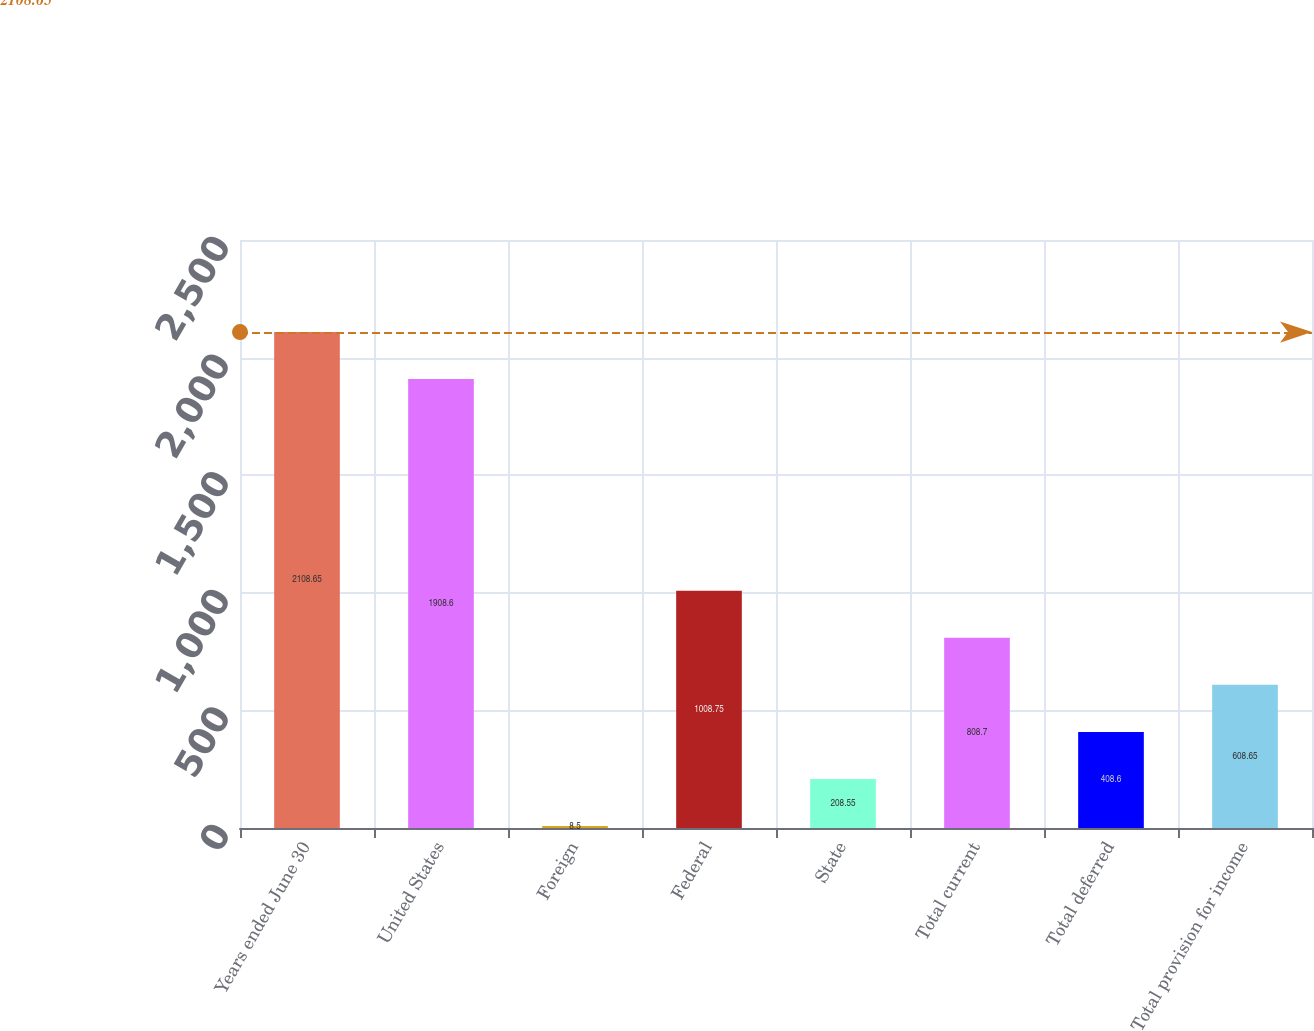Convert chart. <chart><loc_0><loc_0><loc_500><loc_500><bar_chart><fcel>Years ended June 30<fcel>United States<fcel>Foreign<fcel>Federal<fcel>State<fcel>Total current<fcel>Total deferred<fcel>Total provision for income<nl><fcel>2108.65<fcel>1908.6<fcel>8.5<fcel>1008.75<fcel>208.55<fcel>808.7<fcel>408.6<fcel>608.65<nl></chart> 